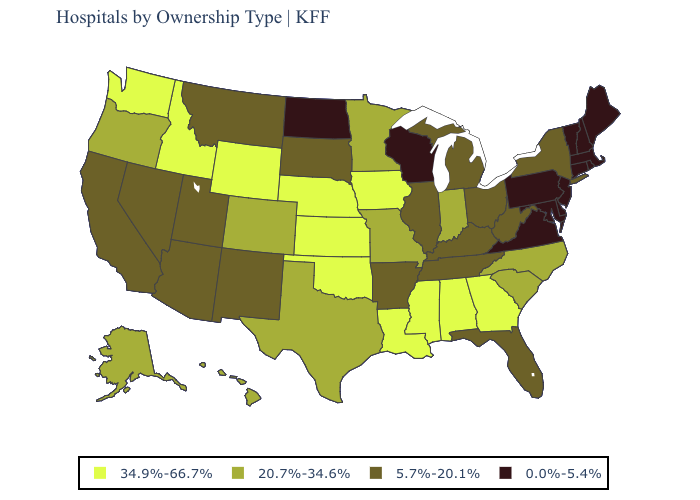Among the states that border Arkansas , which have the highest value?
Keep it brief. Louisiana, Mississippi, Oklahoma. Which states hav the highest value in the South?
Quick response, please. Alabama, Georgia, Louisiana, Mississippi, Oklahoma. Is the legend a continuous bar?
Short answer required. No. Does Idaho have the highest value in the USA?
Be succinct. Yes. Does Wisconsin have the lowest value in the MidWest?
Quick response, please. Yes. What is the value of Arkansas?
Keep it brief. 5.7%-20.1%. Name the states that have a value in the range 0.0%-5.4%?
Give a very brief answer. Connecticut, Delaware, Maine, Maryland, Massachusetts, New Hampshire, New Jersey, North Dakota, Pennsylvania, Rhode Island, Vermont, Virginia, Wisconsin. Name the states that have a value in the range 20.7%-34.6%?
Write a very short answer. Alaska, Colorado, Hawaii, Indiana, Minnesota, Missouri, North Carolina, Oregon, South Carolina, Texas. Does New Mexico have the same value as Michigan?
Write a very short answer. Yes. Name the states that have a value in the range 5.7%-20.1%?
Give a very brief answer. Arizona, Arkansas, California, Florida, Illinois, Kentucky, Michigan, Montana, Nevada, New Mexico, New York, Ohio, South Dakota, Tennessee, Utah, West Virginia. Does the first symbol in the legend represent the smallest category?
Write a very short answer. No. Does the map have missing data?
Write a very short answer. No. Which states have the lowest value in the West?
Quick response, please. Arizona, California, Montana, Nevada, New Mexico, Utah. Does the first symbol in the legend represent the smallest category?
Short answer required. No. What is the lowest value in the USA?
Keep it brief. 0.0%-5.4%. 